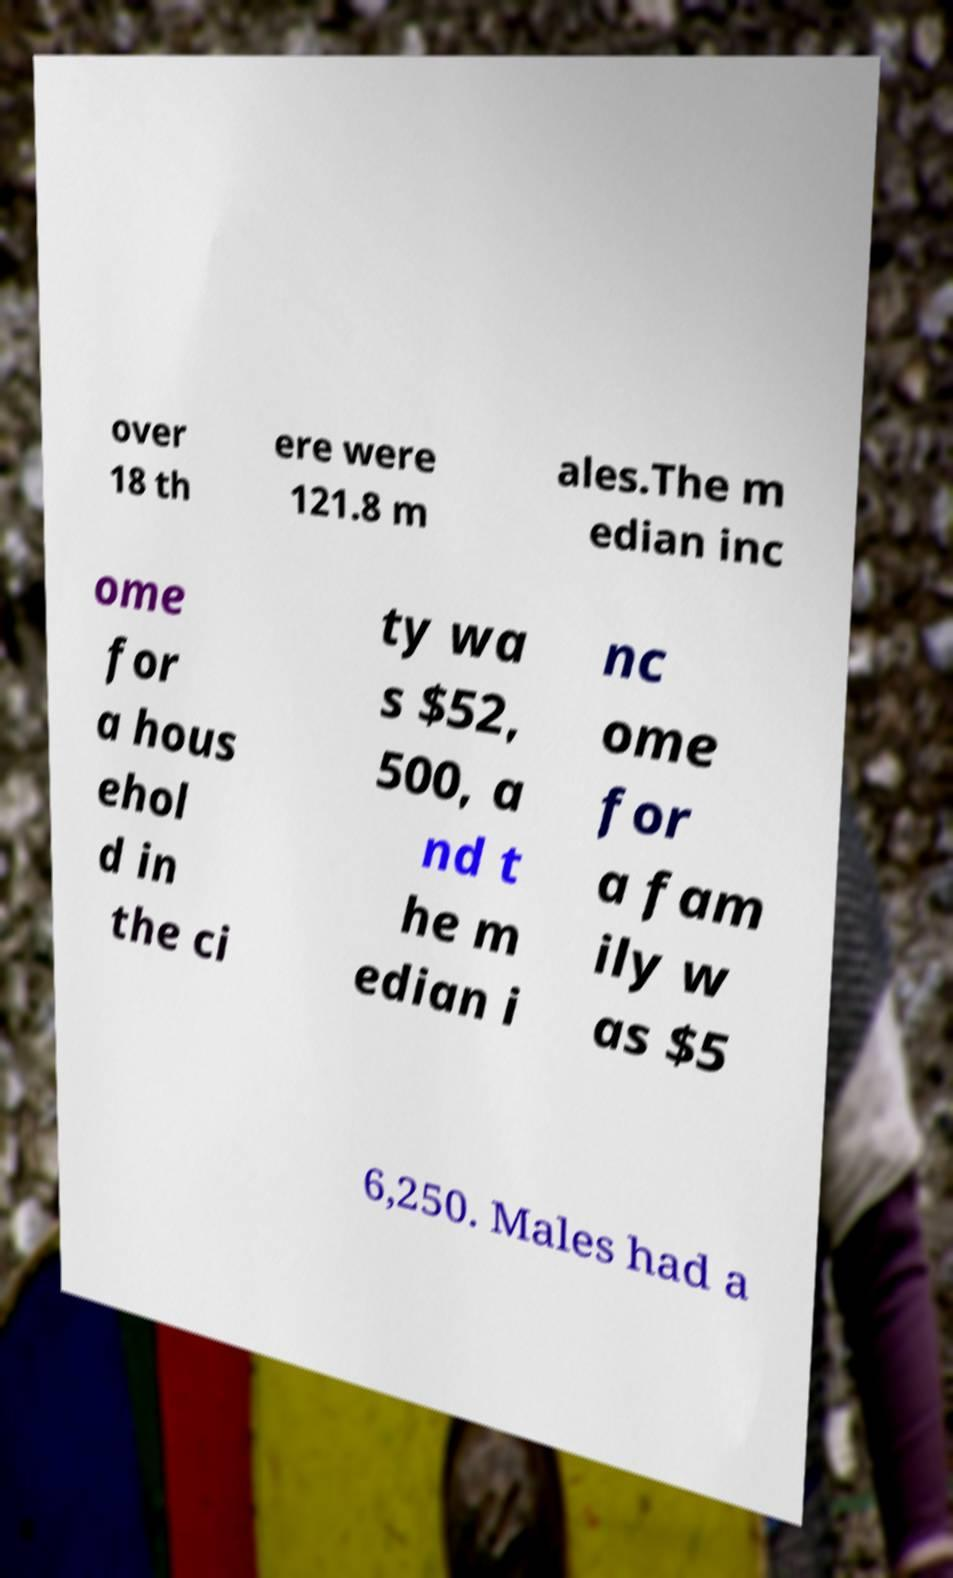Can you read and provide the text displayed in the image?This photo seems to have some interesting text. Can you extract and type it out for me? over 18 th ere were 121.8 m ales.The m edian inc ome for a hous ehol d in the ci ty wa s $52, 500, a nd t he m edian i nc ome for a fam ily w as $5 6,250. Males had a 